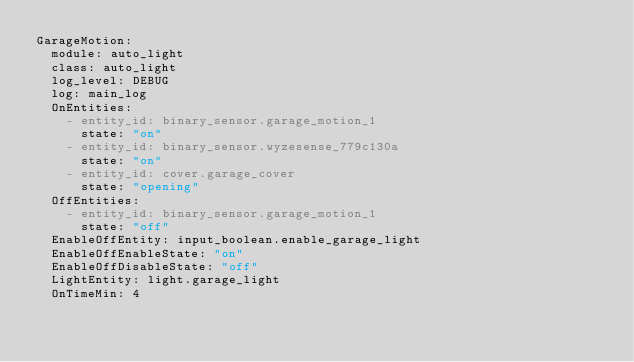Convert code to text. <code><loc_0><loc_0><loc_500><loc_500><_YAML_>GarageMotion:
  module: auto_light
  class: auto_light
  log_level: DEBUG
  log: main_log
  OnEntities:
    - entity_id: binary_sensor.garage_motion_1
      state: "on"
    - entity_id: binary_sensor.wyzesense_779c130a
      state: "on"
    - entity_id: cover.garage_cover
      state: "opening"
  OffEntities:
    - entity_id: binary_sensor.garage_motion_1
      state: "off"
  EnableOffEntity: input_boolean.enable_garage_light
  EnableOffEnableState: "on"
  EnableOffDisableState: "off"
  LightEntity: light.garage_light
  OnTimeMin: 4

</code> 